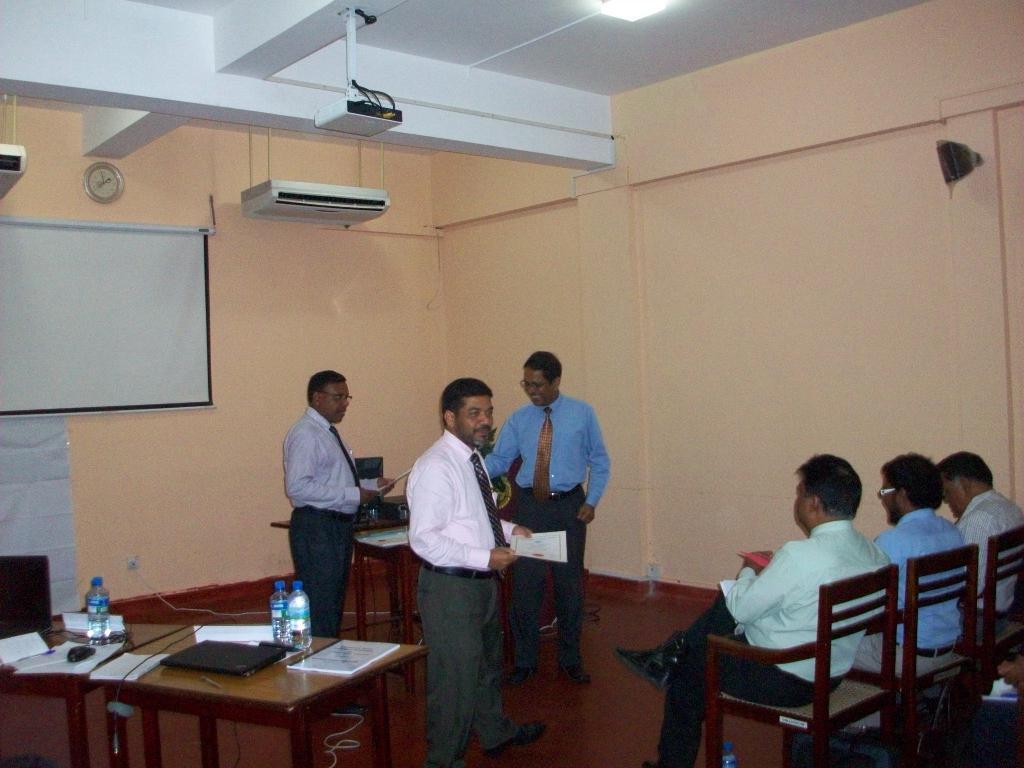Describe this image in one or two sentences. In a room, there is some meeting going on, three people were sitting on the chairs and in front of them three other men are standing and they are holding some papers with their hand. On the left side there is a table and on the table there is a water bottle, laptop and some books. In the background there is a wall and there is a projector screen fixed to the wall and the projector is hanged to the roof. 